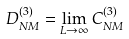<formula> <loc_0><loc_0><loc_500><loc_500>D _ { N M } ^ { ( 3 ) } = \lim _ { L \to \infty } C _ { N M } ^ { ( 3 ) }</formula> 